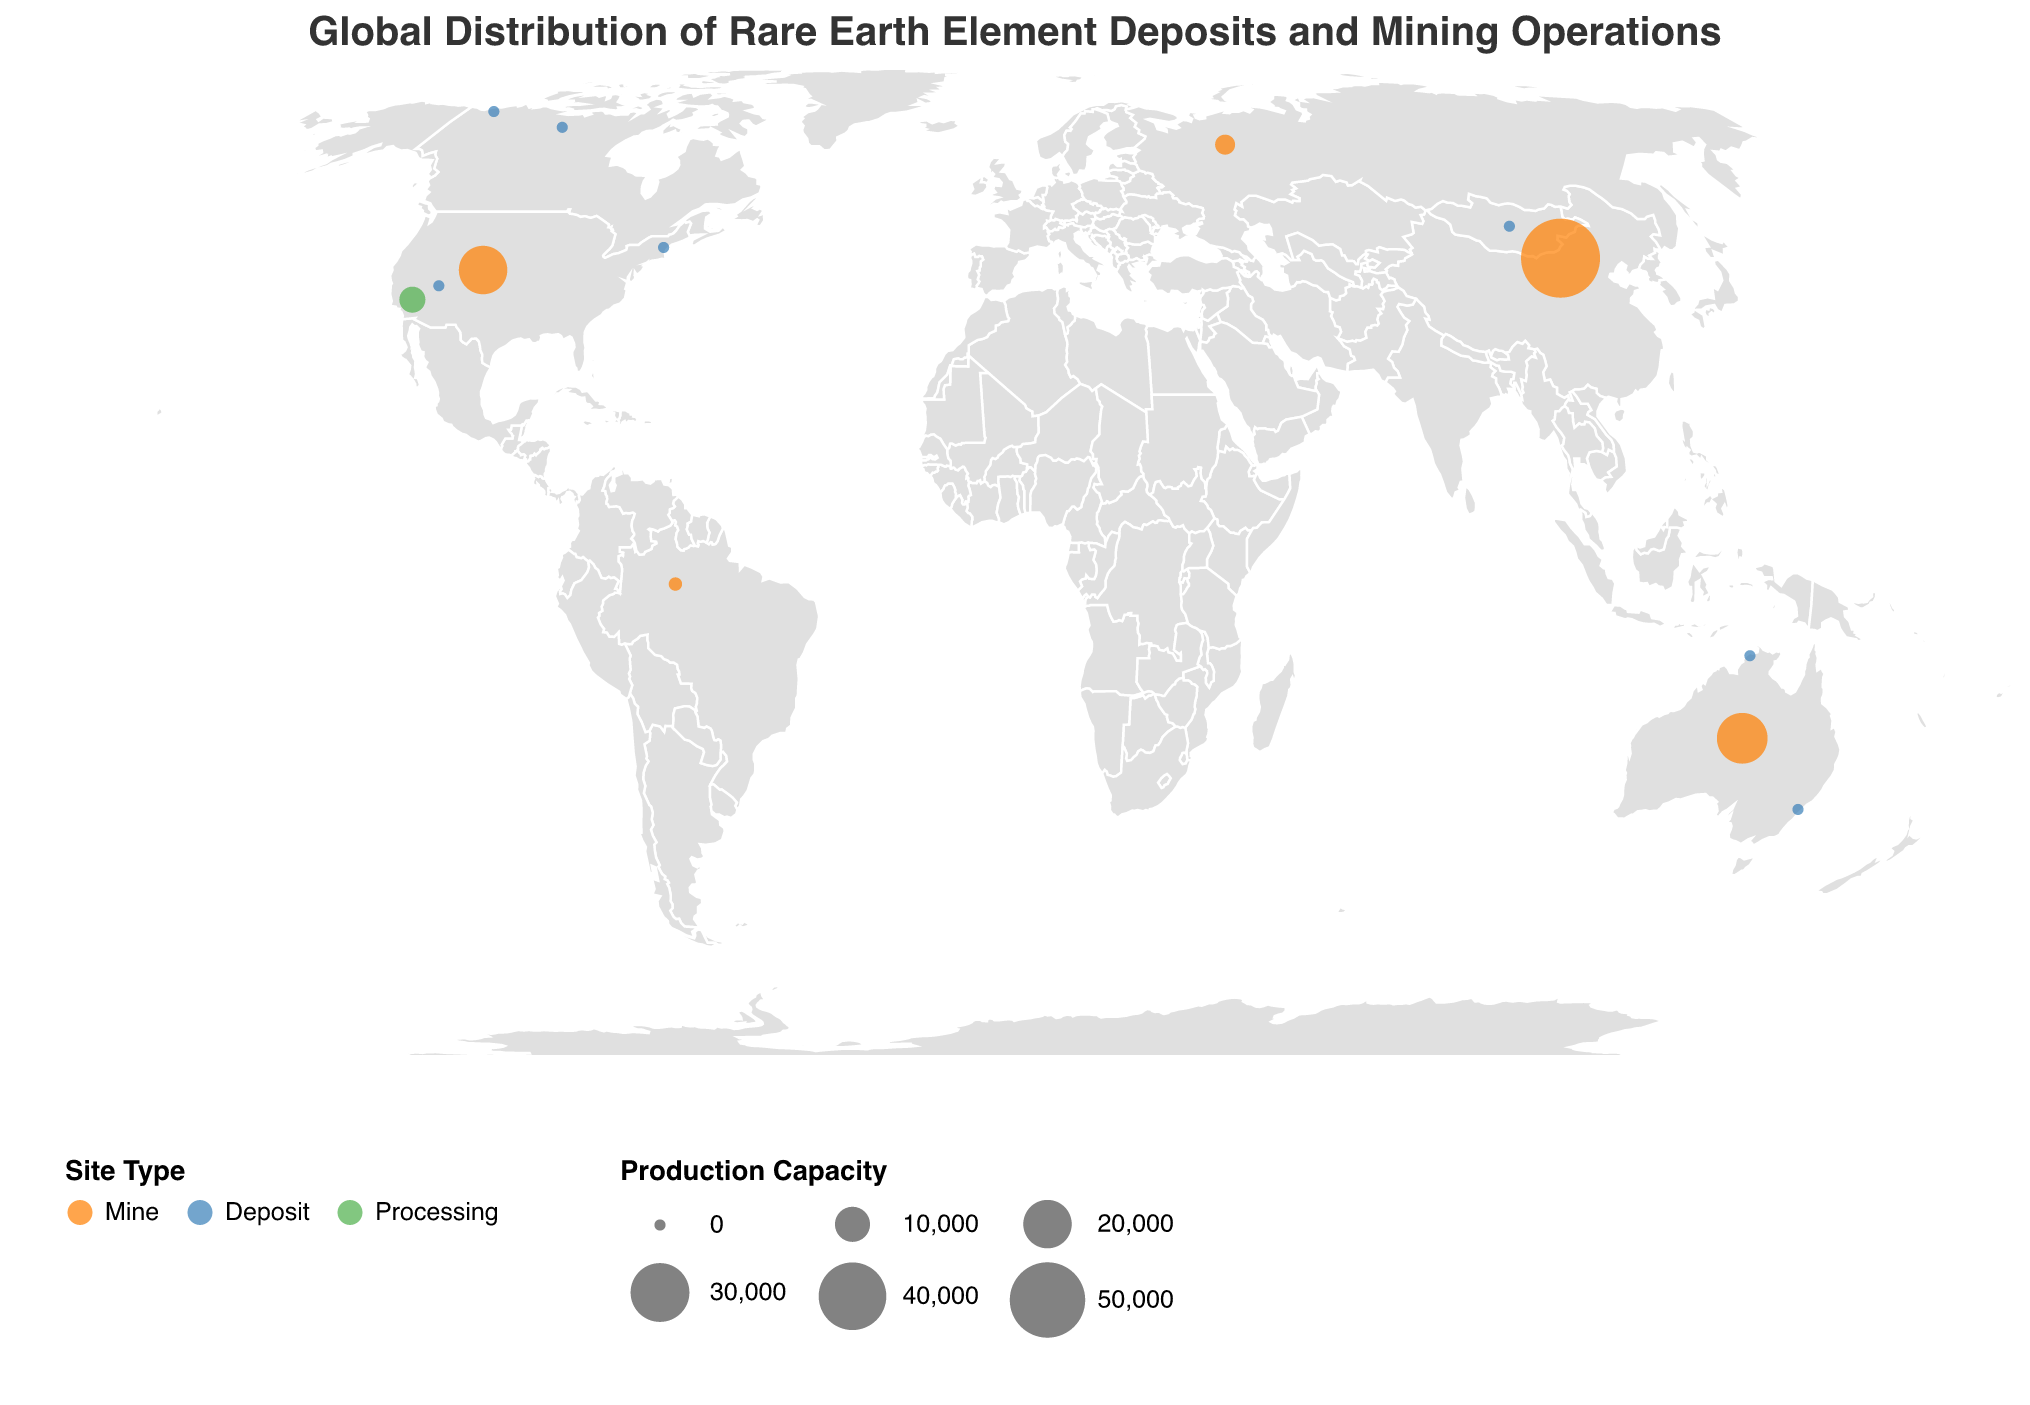What is the title of the figure? The title is usually positioned at the top of the figure and is written to describe the visual in a concise manner. The title here reads "Global Distribution of Rare Earth Element Deposits and Mining Operations".
Answer: Global Distribution of Rare Earth Element Deposits and Mining Operations How many types of sites are represented in the figure? The legend at the bottom of the figure uses color coding to distinguish between different types of sites. There are three color-coded symbols corresponding to three site types: Mine, Deposit, and Processing.
Answer: 3 Which site has the highest production capacity? By examining the size of the circles in the figure, where size indicates production capacity, we can identify that the largest circle corresponds to "Bayan Obo", which has a production capacity of 55,000.
Answer: Bayan Obo How many sites are classified as 'Deposit'? There is a legend that uses colors to differentiate between site types. By counting the number of blue circles in the figure, we can determine there are 7 sites classified as 'Deposit'.
Answer: 7 Which site types are represented in North America? By examining the positions and legends for site types, we observe: Mountain Pass (Mine), Mountain Pass West (Processing), and several deposits: Mineral Mountains, Nechalacho, and Bear Lodge. So, three types are present.
Answer: Mine, Deposit, Processing What is the color coding for "Mine" and "Deposit"? The legend indicates the color coding for each type of site. From the legend, “Mine” is colored orange and “Deposit” is colored blue.
Answer: Orange for Mine, Blue for Deposit Compare the production capacities of Mount Weld and Lovozero. Which one is higher? By comparing the size of circles (which indicates production capacity), Mount Weld (22,000) has a larger circle compared to Lovozero (2,500).
Answer: Mount Weld How many sites produce both Light and Heavy REE? The legend indicates the shape for REE Type. By counting the number of squares (indicating Light and Heavy REE), we find there are 3 sites.
Answer: 3 Which continent has the highest number of identified REE sites? By counting the number of sites displayed on each continent, Asia appears to have the highest number of sites with Bayan Obo, Lugiin Gol, and others.
Answer: Asia What is the shape used for Light REE in the figure? According to the legend, the shapes represent different REE types. Light REE is represented using circles in the plot.
Answer: Circle 